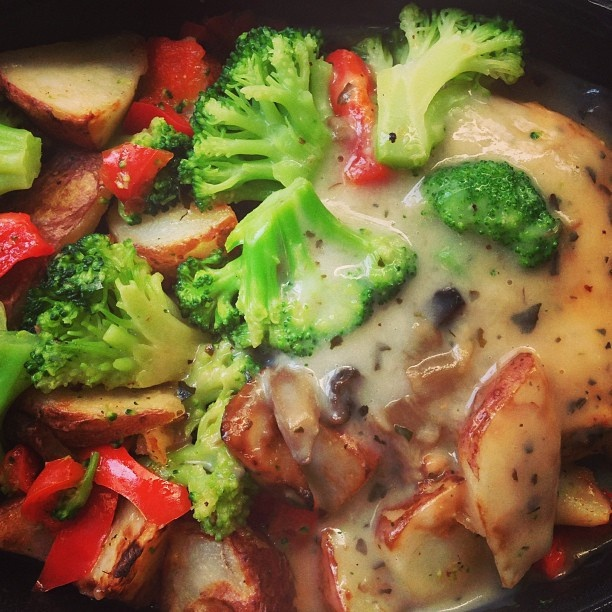Describe the objects in this image and their specific colors. I can see broccoli in black, darkgreen, and olive tones, broccoli in black, lightgreen, green, and khaki tones, broccoli in black, olive, lightgreen, and darkgreen tones, apple in black, brown, tan, and maroon tones, and broccoli in black, khaki, olive, and darkgreen tones in this image. 